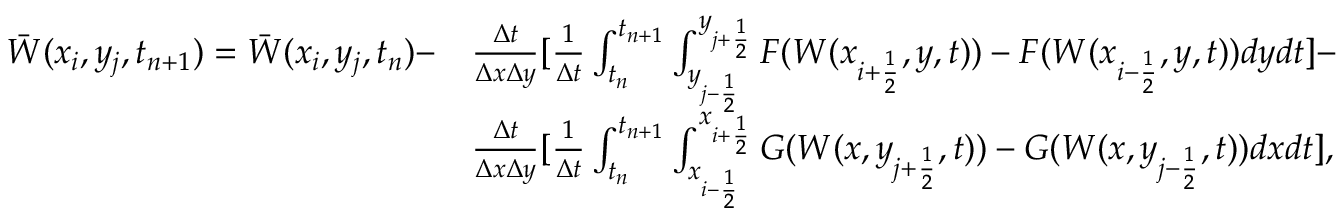<formula> <loc_0><loc_0><loc_500><loc_500>\begin{array} { r l } { \ B a r W ( x _ { i } , y _ { j } , t _ { n + 1 } ) = \ B a r W ( x _ { i } , y _ { j } , t _ { n } ) - } & { \frac { \Delta t } { \Delta x \Delta y } [ \frac { 1 } { \Delta t } \int _ { t _ { n } } ^ { t _ { n + 1 } } \int _ { y _ { j - \frac { 1 } { 2 } } } ^ { y _ { j + \frac { 1 } { 2 } } } F ( W ( x _ { i + \frac { 1 } { 2 } } , y , t ) ) - F ( W ( x _ { i - \frac { 1 } { 2 } } , y , t ) ) d y d t ] - } \\ & { \frac { \Delta t } { \Delta x \Delta y } [ \frac { 1 } { \Delta t } \int _ { t _ { n } } ^ { t _ { n + 1 } } \int _ { x _ { i - \frac { 1 } { 2 } } } ^ { x _ { i + \frac { 1 } { 2 } } } G ( W ( x , y _ { j + \frac { 1 } { 2 } } , t ) ) - G ( W ( x , y _ { j - \frac { 1 } { 2 } } , t ) ) d x d t ] , } \end{array}</formula> 